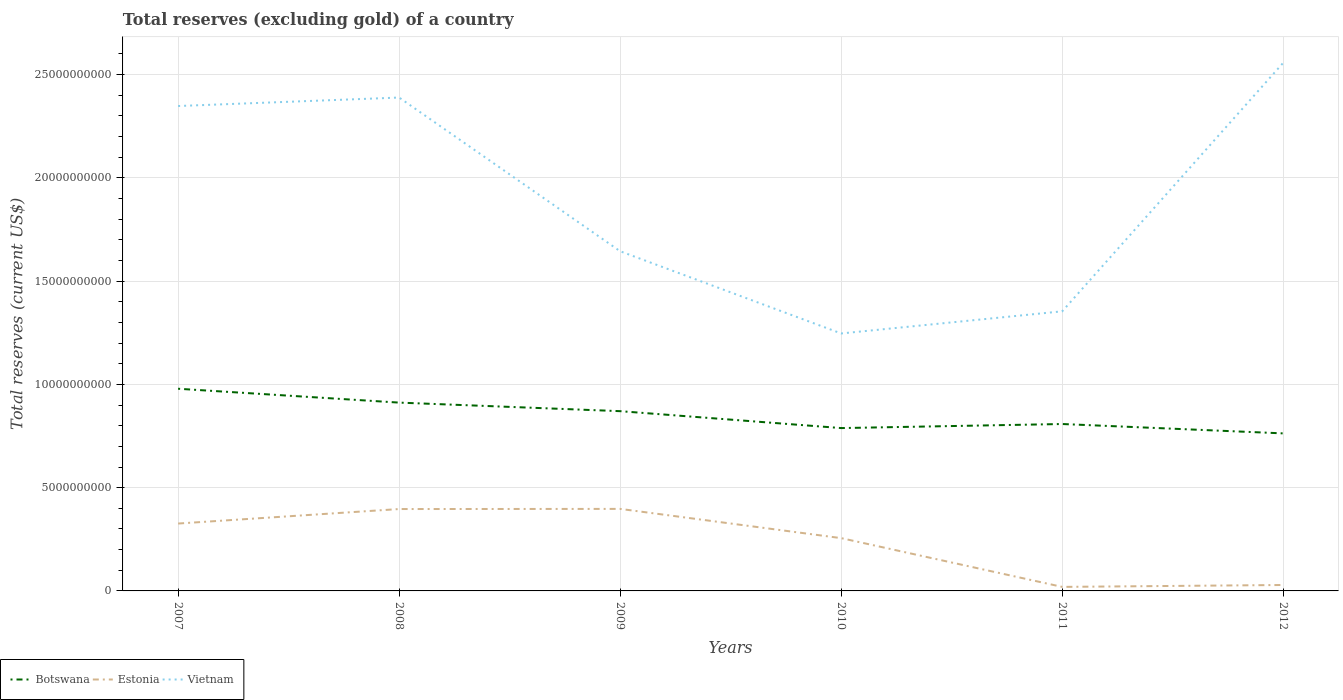How many different coloured lines are there?
Give a very brief answer. 3. Is the number of lines equal to the number of legend labels?
Offer a very short reply. Yes. Across all years, what is the maximum total reserves (excluding gold) in Vietnam?
Provide a succinct answer. 1.25e+1. In which year was the total reserves (excluding gold) in Vietnam maximum?
Provide a succinct answer. 2010. What is the total total reserves (excluding gold) in Vietnam in the graph?
Your answer should be very brief. 1.10e+1. What is the difference between the highest and the second highest total reserves (excluding gold) in Vietnam?
Your response must be concise. 1.31e+1. What is the difference between the highest and the lowest total reserves (excluding gold) in Estonia?
Ensure brevity in your answer.  4. Is the total reserves (excluding gold) in Vietnam strictly greater than the total reserves (excluding gold) in Estonia over the years?
Ensure brevity in your answer.  No. How many lines are there?
Your answer should be very brief. 3. How many years are there in the graph?
Make the answer very short. 6. Are the values on the major ticks of Y-axis written in scientific E-notation?
Your answer should be compact. No. Does the graph contain any zero values?
Keep it short and to the point. No. Does the graph contain grids?
Your response must be concise. Yes. How many legend labels are there?
Offer a terse response. 3. What is the title of the graph?
Keep it short and to the point. Total reserves (excluding gold) of a country. Does "China" appear as one of the legend labels in the graph?
Provide a short and direct response. No. What is the label or title of the Y-axis?
Provide a short and direct response. Total reserves (current US$). What is the Total reserves (current US$) of Botswana in 2007?
Your response must be concise. 9.79e+09. What is the Total reserves (current US$) of Estonia in 2007?
Provide a short and direct response. 3.26e+09. What is the Total reserves (current US$) of Vietnam in 2007?
Keep it short and to the point. 2.35e+1. What is the Total reserves (current US$) of Botswana in 2008?
Give a very brief answer. 9.12e+09. What is the Total reserves (current US$) of Estonia in 2008?
Offer a terse response. 3.96e+09. What is the Total reserves (current US$) in Vietnam in 2008?
Your answer should be compact. 2.39e+1. What is the Total reserves (current US$) of Botswana in 2009?
Offer a terse response. 8.70e+09. What is the Total reserves (current US$) in Estonia in 2009?
Your answer should be very brief. 3.97e+09. What is the Total reserves (current US$) in Vietnam in 2009?
Provide a short and direct response. 1.64e+1. What is the Total reserves (current US$) in Botswana in 2010?
Keep it short and to the point. 7.89e+09. What is the Total reserves (current US$) in Estonia in 2010?
Make the answer very short. 2.56e+09. What is the Total reserves (current US$) in Vietnam in 2010?
Your response must be concise. 1.25e+1. What is the Total reserves (current US$) in Botswana in 2011?
Make the answer very short. 8.08e+09. What is the Total reserves (current US$) in Estonia in 2011?
Offer a very short reply. 1.95e+08. What is the Total reserves (current US$) in Vietnam in 2011?
Offer a very short reply. 1.35e+1. What is the Total reserves (current US$) in Botswana in 2012?
Provide a succinct answer. 7.63e+09. What is the Total reserves (current US$) in Estonia in 2012?
Offer a very short reply. 2.87e+08. What is the Total reserves (current US$) in Vietnam in 2012?
Provide a short and direct response. 2.56e+1. Across all years, what is the maximum Total reserves (current US$) of Botswana?
Keep it short and to the point. 9.79e+09. Across all years, what is the maximum Total reserves (current US$) in Estonia?
Your response must be concise. 3.97e+09. Across all years, what is the maximum Total reserves (current US$) in Vietnam?
Offer a very short reply. 2.56e+1. Across all years, what is the minimum Total reserves (current US$) in Botswana?
Give a very brief answer. 7.63e+09. Across all years, what is the minimum Total reserves (current US$) in Estonia?
Provide a succinct answer. 1.95e+08. Across all years, what is the minimum Total reserves (current US$) in Vietnam?
Ensure brevity in your answer.  1.25e+1. What is the total Total reserves (current US$) in Botswana in the graph?
Provide a succinct answer. 5.12e+1. What is the total Total reserves (current US$) in Estonia in the graph?
Keep it short and to the point. 1.42e+1. What is the total Total reserves (current US$) of Vietnam in the graph?
Provide a succinct answer. 1.15e+11. What is the difference between the Total reserves (current US$) in Botswana in 2007 and that in 2008?
Offer a very short reply. 6.71e+08. What is the difference between the Total reserves (current US$) of Estonia in 2007 and that in 2008?
Your answer should be compact. -7.02e+08. What is the difference between the Total reserves (current US$) in Vietnam in 2007 and that in 2008?
Make the answer very short. -4.11e+08. What is the difference between the Total reserves (current US$) in Botswana in 2007 and that in 2009?
Provide a short and direct response. 1.09e+09. What is the difference between the Total reserves (current US$) of Estonia in 2007 and that in 2009?
Your response must be concise. -7.09e+08. What is the difference between the Total reserves (current US$) in Vietnam in 2007 and that in 2009?
Offer a terse response. 7.03e+09. What is the difference between the Total reserves (current US$) of Botswana in 2007 and that in 2010?
Ensure brevity in your answer.  1.90e+09. What is the difference between the Total reserves (current US$) in Estonia in 2007 and that in 2010?
Offer a terse response. 7.07e+08. What is the difference between the Total reserves (current US$) in Vietnam in 2007 and that in 2010?
Ensure brevity in your answer.  1.10e+1. What is the difference between the Total reserves (current US$) in Botswana in 2007 and that in 2011?
Ensure brevity in your answer.  1.71e+09. What is the difference between the Total reserves (current US$) in Estonia in 2007 and that in 2011?
Offer a very short reply. 3.07e+09. What is the difference between the Total reserves (current US$) in Vietnam in 2007 and that in 2011?
Provide a succinct answer. 9.94e+09. What is the difference between the Total reserves (current US$) in Botswana in 2007 and that in 2012?
Make the answer very short. 2.16e+09. What is the difference between the Total reserves (current US$) of Estonia in 2007 and that in 2012?
Give a very brief answer. 2.98e+09. What is the difference between the Total reserves (current US$) of Vietnam in 2007 and that in 2012?
Keep it short and to the point. -2.09e+09. What is the difference between the Total reserves (current US$) in Botswana in 2008 and that in 2009?
Ensure brevity in your answer.  4.15e+08. What is the difference between the Total reserves (current US$) in Estonia in 2008 and that in 2009?
Your answer should be compact. -7.06e+06. What is the difference between the Total reserves (current US$) in Vietnam in 2008 and that in 2009?
Provide a short and direct response. 7.44e+09. What is the difference between the Total reserves (current US$) in Botswana in 2008 and that in 2010?
Your response must be concise. 1.23e+09. What is the difference between the Total reserves (current US$) in Estonia in 2008 and that in 2010?
Your response must be concise. 1.41e+09. What is the difference between the Total reserves (current US$) in Vietnam in 2008 and that in 2010?
Make the answer very short. 1.14e+1. What is the difference between the Total reserves (current US$) of Botswana in 2008 and that in 2011?
Your answer should be very brief. 1.04e+09. What is the difference between the Total reserves (current US$) in Estonia in 2008 and that in 2011?
Ensure brevity in your answer.  3.77e+09. What is the difference between the Total reserves (current US$) of Vietnam in 2008 and that in 2011?
Make the answer very short. 1.04e+1. What is the difference between the Total reserves (current US$) of Botswana in 2008 and that in 2012?
Provide a succinct answer. 1.49e+09. What is the difference between the Total reserves (current US$) in Estonia in 2008 and that in 2012?
Your response must be concise. 3.68e+09. What is the difference between the Total reserves (current US$) in Vietnam in 2008 and that in 2012?
Provide a short and direct response. -1.68e+09. What is the difference between the Total reserves (current US$) in Botswana in 2009 and that in 2010?
Provide a short and direct response. 8.19e+08. What is the difference between the Total reserves (current US$) in Estonia in 2009 and that in 2010?
Keep it short and to the point. 1.42e+09. What is the difference between the Total reserves (current US$) of Vietnam in 2009 and that in 2010?
Your response must be concise. 3.98e+09. What is the difference between the Total reserves (current US$) in Botswana in 2009 and that in 2011?
Keep it short and to the point. 6.22e+08. What is the difference between the Total reserves (current US$) in Estonia in 2009 and that in 2011?
Provide a succinct answer. 3.78e+09. What is the difference between the Total reserves (current US$) of Vietnam in 2009 and that in 2011?
Your answer should be very brief. 2.91e+09. What is the difference between the Total reserves (current US$) of Botswana in 2009 and that in 2012?
Provide a short and direct response. 1.08e+09. What is the difference between the Total reserves (current US$) of Estonia in 2009 and that in 2012?
Ensure brevity in your answer.  3.68e+09. What is the difference between the Total reserves (current US$) in Vietnam in 2009 and that in 2012?
Your answer should be compact. -9.13e+09. What is the difference between the Total reserves (current US$) in Botswana in 2010 and that in 2011?
Keep it short and to the point. -1.97e+08. What is the difference between the Total reserves (current US$) of Estonia in 2010 and that in 2011?
Ensure brevity in your answer.  2.36e+09. What is the difference between the Total reserves (current US$) in Vietnam in 2010 and that in 2011?
Your answer should be very brief. -1.07e+09. What is the difference between the Total reserves (current US$) in Botswana in 2010 and that in 2012?
Provide a short and direct response. 2.57e+08. What is the difference between the Total reserves (current US$) of Estonia in 2010 and that in 2012?
Provide a succinct answer. 2.27e+09. What is the difference between the Total reserves (current US$) of Vietnam in 2010 and that in 2012?
Offer a terse response. -1.31e+1. What is the difference between the Total reserves (current US$) in Botswana in 2011 and that in 2012?
Your answer should be compact. 4.54e+08. What is the difference between the Total reserves (current US$) in Estonia in 2011 and that in 2012?
Give a very brief answer. -9.25e+07. What is the difference between the Total reserves (current US$) in Vietnam in 2011 and that in 2012?
Make the answer very short. -1.20e+1. What is the difference between the Total reserves (current US$) in Botswana in 2007 and the Total reserves (current US$) in Estonia in 2008?
Your response must be concise. 5.82e+09. What is the difference between the Total reserves (current US$) of Botswana in 2007 and the Total reserves (current US$) of Vietnam in 2008?
Your response must be concise. -1.41e+1. What is the difference between the Total reserves (current US$) in Estonia in 2007 and the Total reserves (current US$) in Vietnam in 2008?
Offer a terse response. -2.06e+1. What is the difference between the Total reserves (current US$) of Botswana in 2007 and the Total reserves (current US$) of Estonia in 2009?
Your answer should be very brief. 5.82e+09. What is the difference between the Total reserves (current US$) in Botswana in 2007 and the Total reserves (current US$) in Vietnam in 2009?
Make the answer very short. -6.66e+09. What is the difference between the Total reserves (current US$) of Estonia in 2007 and the Total reserves (current US$) of Vietnam in 2009?
Offer a terse response. -1.32e+1. What is the difference between the Total reserves (current US$) in Botswana in 2007 and the Total reserves (current US$) in Estonia in 2010?
Offer a terse response. 7.23e+09. What is the difference between the Total reserves (current US$) of Botswana in 2007 and the Total reserves (current US$) of Vietnam in 2010?
Your answer should be compact. -2.68e+09. What is the difference between the Total reserves (current US$) in Estonia in 2007 and the Total reserves (current US$) in Vietnam in 2010?
Your answer should be compact. -9.20e+09. What is the difference between the Total reserves (current US$) of Botswana in 2007 and the Total reserves (current US$) of Estonia in 2011?
Make the answer very short. 9.59e+09. What is the difference between the Total reserves (current US$) in Botswana in 2007 and the Total reserves (current US$) in Vietnam in 2011?
Keep it short and to the point. -3.75e+09. What is the difference between the Total reserves (current US$) in Estonia in 2007 and the Total reserves (current US$) in Vietnam in 2011?
Provide a succinct answer. -1.03e+1. What is the difference between the Total reserves (current US$) in Botswana in 2007 and the Total reserves (current US$) in Estonia in 2012?
Ensure brevity in your answer.  9.50e+09. What is the difference between the Total reserves (current US$) in Botswana in 2007 and the Total reserves (current US$) in Vietnam in 2012?
Provide a short and direct response. -1.58e+1. What is the difference between the Total reserves (current US$) in Estonia in 2007 and the Total reserves (current US$) in Vietnam in 2012?
Give a very brief answer. -2.23e+1. What is the difference between the Total reserves (current US$) of Botswana in 2008 and the Total reserves (current US$) of Estonia in 2009?
Your response must be concise. 5.15e+09. What is the difference between the Total reserves (current US$) in Botswana in 2008 and the Total reserves (current US$) in Vietnam in 2009?
Offer a terse response. -7.33e+09. What is the difference between the Total reserves (current US$) of Estonia in 2008 and the Total reserves (current US$) of Vietnam in 2009?
Give a very brief answer. -1.25e+1. What is the difference between the Total reserves (current US$) of Botswana in 2008 and the Total reserves (current US$) of Estonia in 2010?
Your answer should be very brief. 6.56e+09. What is the difference between the Total reserves (current US$) of Botswana in 2008 and the Total reserves (current US$) of Vietnam in 2010?
Ensure brevity in your answer.  -3.35e+09. What is the difference between the Total reserves (current US$) of Estonia in 2008 and the Total reserves (current US$) of Vietnam in 2010?
Offer a terse response. -8.50e+09. What is the difference between the Total reserves (current US$) in Botswana in 2008 and the Total reserves (current US$) in Estonia in 2011?
Your answer should be very brief. 8.92e+09. What is the difference between the Total reserves (current US$) of Botswana in 2008 and the Total reserves (current US$) of Vietnam in 2011?
Provide a short and direct response. -4.42e+09. What is the difference between the Total reserves (current US$) in Estonia in 2008 and the Total reserves (current US$) in Vietnam in 2011?
Provide a short and direct response. -9.57e+09. What is the difference between the Total reserves (current US$) of Botswana in 2008 and the Total reserves (current US$) of Estonia in 2012?
Your answer should be very brief. 8.83e+09. What is the difference between the Total reserves (current US$) in Botswana in 2008 and the Total reserves (current US$) in Vietnam in 2012?
Your answer should be compact. -1.65e+1. What is the difference between the Total reserves (current US$) in Estonia in 2008 and the Total reserves (current US$) in Vietnam in 2012?
Ensure brevity in your answer.  -2.16e+1. What is the difference between the Total reserves (current US$) of Botswana in 2009 and the Total reserves (current US$) of Estonia in 2010?
Provide a short and direct response. 6.15e+09. What is the difference between the Total reserves (current US$) in Botswana in 2009 and the Total reserves (current US$) in Vietnam in 2010?
Your response must be concise. -3.76e+09. What is the difference between the Total reserves (current US$) in Estonia in 2009 and the Total reserves (current US$) in Vietnam in 2010?
Keep it short and to the point. -8.49e+09. What is the difference between the Total reserves (current US$) in Botswana in 2009 and the Total reserves (current US$) in Estonia in 2011?
Offer a terse response. 8.51e+09. What is the difference between the Total reserves (current US$) in Botswana in 2009 and the Total reserves (current US$) in Vietnam in 2011?
Your answer should be compact. -4.84e+09. What is the difference between the Total reserves (current US$) in Estonia in 2009 and the Total reserves (current US$) in Vietnam in 2011?
Your response must be concise. -9.57e+09. What is the difference between the Total reserves (current US$) of Botswana in 2009 and the Total reserves (current US$) of Estonia in 2012?
Your answer should be compact. 8.42e+09. What is the difference between the Total reserves (current US$) in Botswana in 2009 and the Total reserves (current US$) in Vietnam in 2012?
Provide a succinct answer. -1.69e+1. What is the difference between the Total reserves (current US$) of Estonia in 2009 and the Total reserves (current US$) of Vietnam in 2012?
Ensure brevity in your answer.  -2.16e+1. What is the difference between the Total reserves (current US$) in Botswana in 2010 and the Total reserves (current US$) in Estonia in 2011?
Your response must be concise. 7.69e+09. What is the difference between the Total reserves (current US$) of Botswana in 2010 and the Total reserves (current US$) of Vietnam in 2011?
Offer a very short reply. -5.65e+09. What is the difference between the Total reserves (current US$) in Estonia in 2010 and the Total reserves (current US$) in Vietnam in 2011?
Ensure brevity in your answer.  -1.10e+1. What is the difference between the Total reserves (current US$) of Botswana in 2010 and the Total reserves (current US$) of Estonia in 2012?
Provide a succinct answer. 7.60e+09. What is the difference between the Total reserves (current US$) of Botswana in 2010 and the Total reserves (current US$) of Vietnam in 2012?
Keep it short and to the point. -1.77e+1. What is the difference between the Total reserves (current US$) of Estonia in 2010 and the Total reserves (current US$) of Vietnam in 2012?
Offer a terse response. -2.30e+1. What is the difference between the Total reserves (current US$) in Botswana in 2011 and the Total reserves (current US$) in Estonia in 2012?
Make the answer very short. 7.79e+09. What is the difference between the Total reserves (current US$) in Botswana in 2011 and the Total reserves (current US$) in Vietnam in 2012?
Keep it short and to the point. -1.75e+1. What is the difference between the Total reserves (current US$) of Estonia in 2011 and the Total reserves (current US$) of Vietnam in 2012?
Your answer should be very brief. -2.54e+1. What is the average Total reserves (current US$) in Botswana per year?
Your answer should be compact. 8.53e+09. What is the average Total reserves (current US$) of Estonia per year?
Offer a terse response. 2.37e+09. What is the average Total reserves (current US$) in Vietnam per year?
Ensure brevity in your answer.  1.92e+1. In the year 2007, what is the difference between the Total reserves (current US$) of Botswana and Total reserves (current US$) of Estonia?
Your answer should be very brief. 6.53e+09. In the year 2007, what is the difference between the Total reserves (current US$) in Botswana and Total reserves (current US$) in Vietnam?
Provide a succinct answer. -1.37e+1. In the year 2007, what is the difference between the Total reserves (current US$) in Estonia and Total reserves (current US$) in Vietnam?
Offer a very short reply. -2.02e+1. In the year 2008, what is the difference between the Total reserves (current US$) of Botswana and Total reserves (current US$) of Estonia?
Offer a very short reply. 5.15e+09. In the year 2008, what is the difference between the Total reserves (current US$) of Botswana and Total reserves (current US$) of Vietnam?
Make the answer very short. -1.48e+1. In the year 2008, what is the difference between the Total reserves (current US$) in Estonia and Total reserves (current US$) in Vietnam?
Provide a short and direct response. -1.99e+1. In the year 2009, what is the difference between the Total reserves (current US$) in Botswana and Total reserves (current US$) in Estonia?
Give a very brief answer. 4.73e+09. In the year 2009, what is the difference between the Total reserves (current US$) of Botswana and Total reserves (current US$) of Vietnam?
Ensure brevity in your answer.  -7.74e+09. In the year 2009, what is the difference between the Total reserves (current US$) in Estonia and Total reserves (current US$) in Vietnam?
Give a very brief answer. -1.25e+1. In the year 2010, what is the difference between the Total reserves (current US$) in Botswana and Total reserves (current US$) in Estonia?
Ensure brevity in your answer.  5.33e+09. In the year 2010, what is the difference between the Total reserves (current US$) of Botswana and Total reserves (current US$) of Vietnam?
Provide a succinct answer. -4.58e+09. In the year 2010, what is the difference between the Total reserves (current US$) in Estonia and Total reserves (current US$) in Vietnam?
Keep it short and to the point. -9.91e+09. In the year 2011, what is the difference between the Total reserves (current US$) of Botswana and Total reserves (current US$) of Estonia?
Provide a short and direct response. 7.89e+09. In the year 2011, what is the difference between the Total reserves (current US$) in Botswana and Total reserves (current US$) in Vietnam?
Offer a terse response. -5.46e+09. In the year 2011, what is the difference between the Total reserves (current US$) in Estonia and Total reserves (current US$) in Vietnam?
Give a very brief answer. -1.33e+1. In the year 2012, what is the difference between the Total reserves (current US$) of Botswana and Total reserves (current US$) of Estonia?
Give a very brief answer. 7.34e+09. In the year 2012, what is the difference between the Total reserves (current US$) of Botswana and Total reserves (current US$) of Vietnam?
Your answer should be compact. -1.79e+1. In the year 2012, what is the difference between the Total reserves (current US$) in Estonia and Total reserves (current US$) in Vietnam?
Your answer should be compact. -2.53e+1. What is the ratio of the Total reserves (current US$) of Botswana in 2007 to that in 2008?
Provide a short and direct response. 1.07. What is the ratio of the Total reserves (current US$) in Estonia in 2007 to that in 2008?
Your answer should be very brief. 0.82. What is the ratio of the Total reserves (current US$) of Vietnam in 2007 to that in 2008?
Make the answer very short. 0.98. What is the ratio of the Total reserves (current US$) in Botswana in 2007 to that in 2009?
Your response must be concise. 1.12. What is the ratio of the Total reserves (current US$) in Estonia in 2007 to that in 2009?
Keep it short and to the point. 0.82. What is the ratio of the Total reserves (current US$) of Vietnam in 2007 to that in 2009?
Offer a very short reply. 1.43. What is the ratio of the Total reserves (current US$) of Botswana in 2007 to that in 2010?
Your response must be concise. 1.24. What is the ratio of the Total reserves (current US$) of Estonia in 2007 to that in 2010?
Your answer should be compact. 1.28. What is the ratio of the Total reserves (current US$) of Vietnam in 2007 to that in 2010?
Provide a succinct answer. 1.88. What is the ratio of the Total reserves (current US$) of Botswana in 2007 to that in 2011?
Offer a terse response. 1.21. What is the ratio of the Total reserves (current US$) of Estonia in 2007 to that in 2011?
Provide a succinct answer. 16.74. What is the ratio of the Total reserves (current US$) of Vietnam in 2007 to that in 2011?
Offer a terse response. 1.73. What is the ratio of the Total reserves (current US$) in Botswana in 2007 to that in 2012?
Make the answer very short. 1.28. What is the ratio of the Total reserves (current US$) in Estonia in 2007 to that in 2012?
Provide a succinct answer. 11.35. What is the ratio of the Total reserves (current US$) in Vietnam in 2007 to that in 2012?
Provide a short and direct response. 0.92. What is the ratio of the Total reserves (current US$) of Botswana in 2008 to that in 2009?
Ensure brevity in your answer.  1.05. What is the ratio of the Total reserves (current US$) of Vietnam in 2008 to that in 2009?
Provide a short and direct response. 1.45. What is the ratio of the Total reserves (current US$) in Botswana in 2008 to that in 2010?
Your answer should be compact. 1.16. What is the ratio of the Total reserves (current US$) of Estonia in 2008 to that in 2010?
Provide a short and direct response. 1.55. What is the ratio of the Total reserves (current US$) of Vietnam in 2008 to that in 2010?
Provide a short and direct response. 1.92. What is the ratio of the Total reserves (current US$) of Botswana in 2008 to that in 2011?
Provide a succinct answer. 1.13. What is the ratio of the Total reserves (current US$) of Estonia in 2008 to that in 2011?
Provide a succinct answer. 20.35. What is the ratio of the Total reserves (current US$) of Vietnam in 2008 to that in 2011?
Provide a short and direct response. 1.76. What is the ratio of the Total reserves (current US$) in Botswana in 2008 to that in 2012?
Keep it short and to the point. 1.2. What is the ratio of the Total reserves (current US$) in Estonia in 2008 to that in 2012?
Your response must be concise. 13.8. What is the ratio of the Total reserves (current US$) in Vietnam in 2008 to that in 2012?
Make the answer very short. 0.93. What is the ratio of the Total reserves (current US$) in Botswana in 2009 to that in 2010?
Your answer should be compact. 1.1. What is the ratio of the Total reserves (current US$) in Estonia in 2009 to that in 2010?
Offer a very short reply. 1.55. What is the ratio of the Total reserves (current US$) of Vietnam in 2009 to that in 2010?
Provide a short and direct response. 1.32. What is the ratio of the Total reserves (current US$) of Botswana in 2009 to that in 2011?
Your answer should be compact. 1.08. What is the ratio of the Total reserves (current US$) in Estonia in 2009 to that in 2011?
Keep it short and to the point. 20.38. What is the ratio of the Total reserves (current US$) in Vietnam in 2009 to that in 2011?
Keep it short and to the point. 1.21. What is the ratio of the Total reserves (current US$) of Botswana in 2009 to that in 2012?
Keep it short and to the point. 1.14. What is the ratio of the Total reserves (current US$) in Estonia in 2009 to that in 2012?
Keep it short and to the point. 13.82. What is the ratio of the Total reserves (current US$) in Vietnam in 2009 to that in 2012?
Provide a short and direct response. 0.64. What is the ratio of the Total reserves (current US$) of Botswana in 2010 to that in 2011?
Your response must be concise. 0.98. What is the ratio of the Total reserves (current US$) in Estonia in 2010 to that in 2011?
Provide a succinct answer. 13.12. What is the ratio of the Total reserves (current US$) of Vietnam in 2010 to that in 2011?
Offer a very short reply. 0.92. What is the ratio of the Total reserves (current US$) in Botswana in 2010 to that in 2012?
Your answer should be very brief. 1.03. What is the ratio of the Total reserves (current US$) of Estonia in 2010 to that in 2012?
Give a very brief answer. 8.89. What is the ratio of the Total reserves (current US$) of Vietnam in 2010 to that in 2012?
Provide a short and direct response. 0.49. What is the ratio of the Total reserves (current US$) in Botswana in 2011 to that in 2012?
Offer a very short reply. 1.06. What is the ratio of the Total reserves (current US$) of Estonia in 2011 to that in 2012?
Give a very brief answer. 0.68. What is the ratio of the Total reserves (current US$) in Vietnam in 2011 to that in 2012?
Give a very brief answer. 0.53. What is the difference between the highest and the second highest Total reserves (current US$) of Botswana?
Your answer should be compact. 6.71e+08. What is the difference between the highest and the second highest Total reserves (current US$) in Estonia?
Make the answer very short. 7.06e+06. What is the difference between the highest and the second highest Total reserves (current US$) in Vietnam?
Give a very brief answer. 1.68e+09. What is the difference between the highest and the lowest Total reserves (current US$) in Botswana?
Ensure brevity in your answer.  2.16e+09. What is the difference between the highest and the lowest Total reserves (current US$) in Estonia?
Ensure brevity in your answer.  3.78e+09. What is the difference between the highest and the lowest Total reserves (current US$) in Vietnam?
Provide a short and direct response. 1.31e+1. 